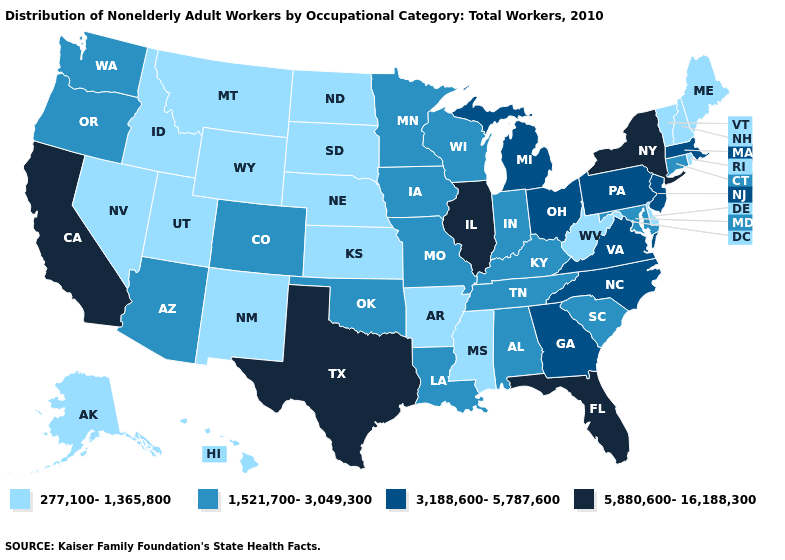Does Iowa have the same value as North Dakota?
Keep it brief. No. What is the value of New Mexico?
Concise answer only. 277,100-1,365,800. How many symbols are there in the legend?
Short answer required. 4. Name the states that have a value in the range 3,188,600-5,787,600?
Give a very brief answer. Georgia, Massachusetts, Michigan, New Jersey, North Carolina, Ohio, Pennsylvania, Virginia. What is the value of Delaware?
Quick response, please. 277,100-1,365,800. What is the highest value in states that border Wisconsin?
Give a very brief answer. 5,880,600-16,188,300. Among the states that border Pennsylvania , does New York have the lowest value?
Short answer required. No. What is the lowest value in the USA?
Concise answer only. 277,100-1,365,800. Name the states that have a value in the range 3,188,600-5,787,600?
Short answer required. Georgia, Massachusetts, Michigan, New Jersey, North Carolina, Ohio, Pennsylvania, Virginia. What is the highest value in the USA?
Write a very short answer. 5,880,600-16,188,300. Name the states that have a value in the range 5,880,600-16,188,300?
Short answer required. California, Florida, Illinois, New York, Texas. Does Mississippi have a lower value than Rhode Island?
Be succinct. No. What is the value of California?
Keep it brief. 5,880,600-16,188,300. Name the states that have a value in the range 1,521,700-3,049,300?
Keep it brief. Alabama, Arizona, Colorado, Connecticut, Indiana, Iowa, Kentucky, Louisiana, Maryland, Minnesota, Missouri, Oklahoma, Oregon, South Carolina, Tennessee, Washington, Wisconsin. Is the legend a continuous bar?
Write a very short answer. No. 